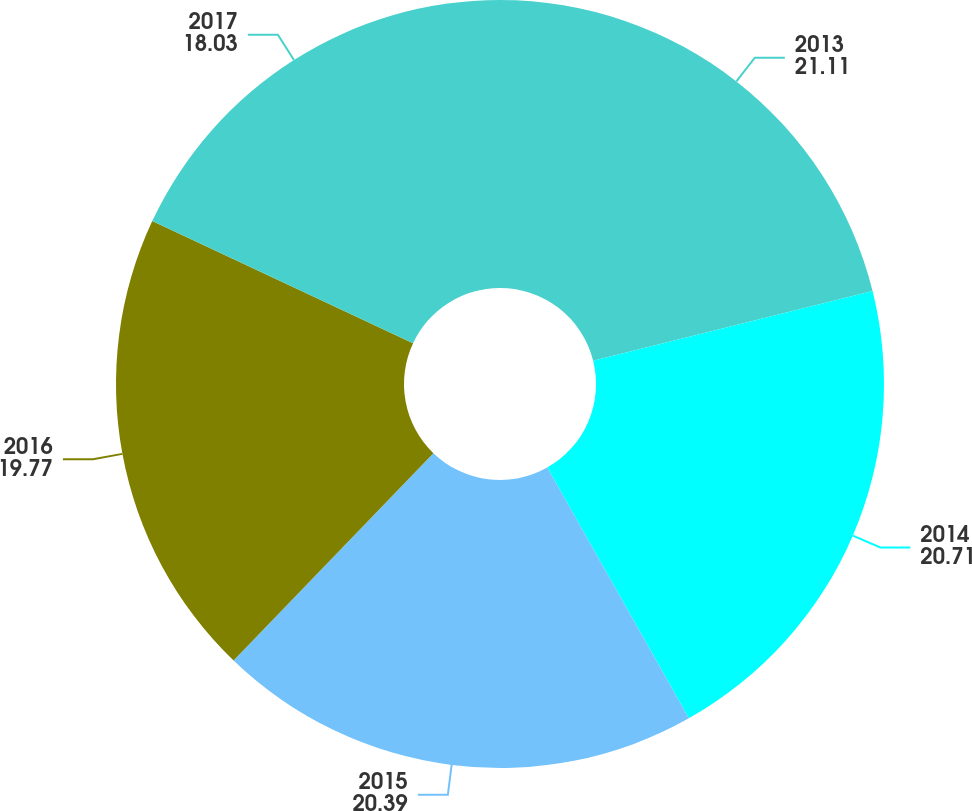<chart> <loc_0><loc_0><loc_500><loc_500><pie_chart><fcel>2013<fcel>2014<fcel>2015<fcel>2016<fcel>2017<nl><fcel>21.11%<fcel>20.71%<fcel>20.39%<fcel>19.77%<fcel>18.03%<nl></chart> 